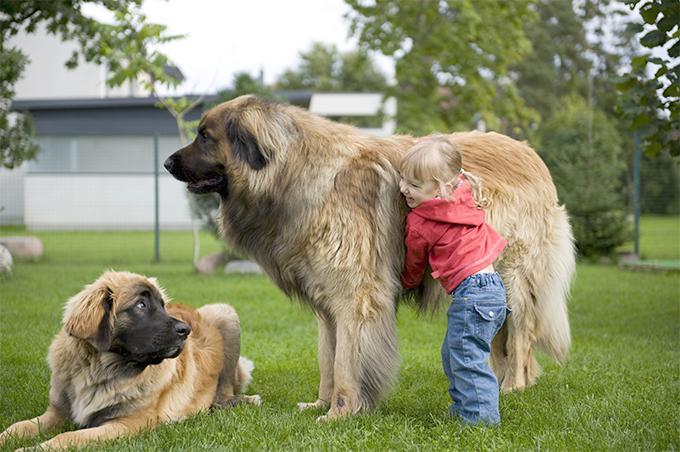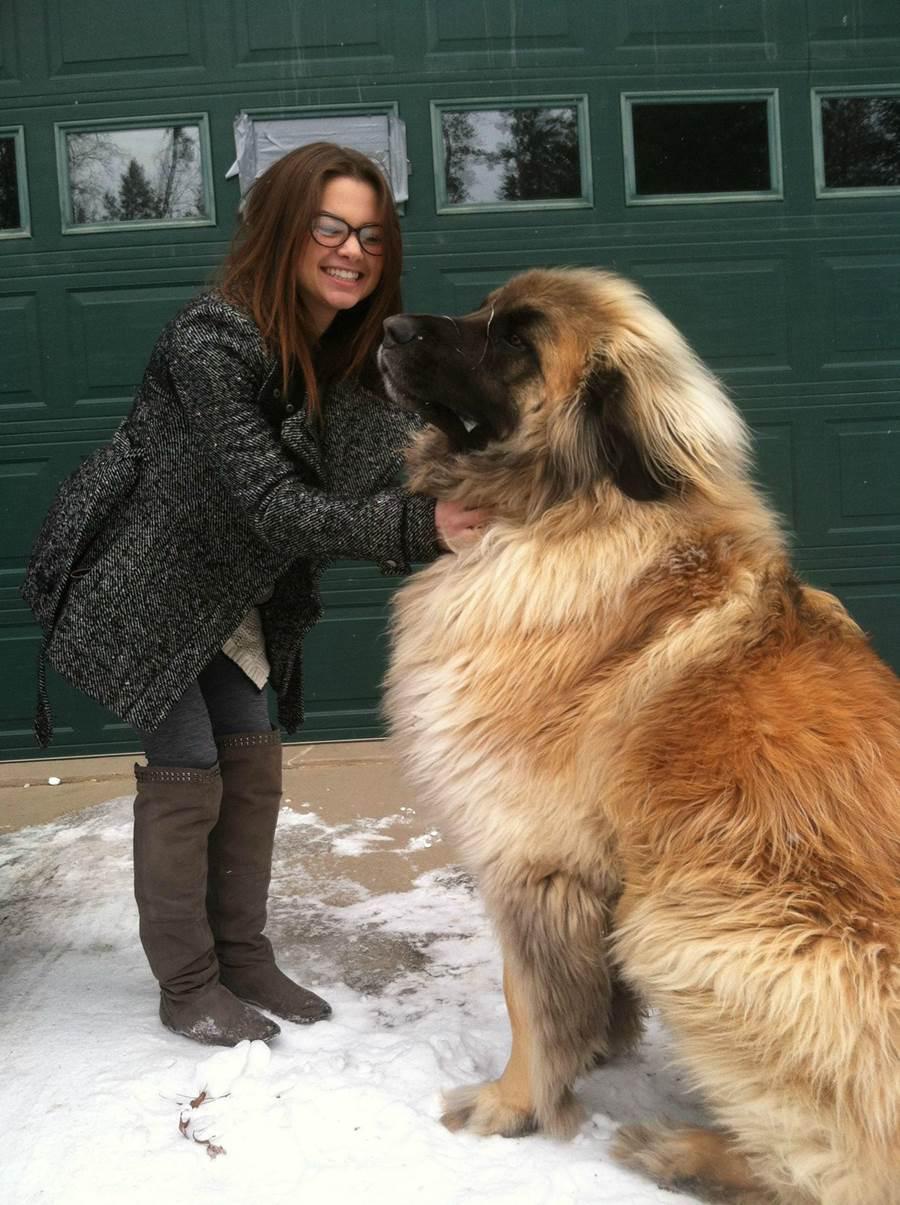The first image is the image on the left, the second image is the image on the right. Given the left and right images, does the statement "A child wearing a red jacket is with a dog." hold true? Answer yes or no. Yes. 